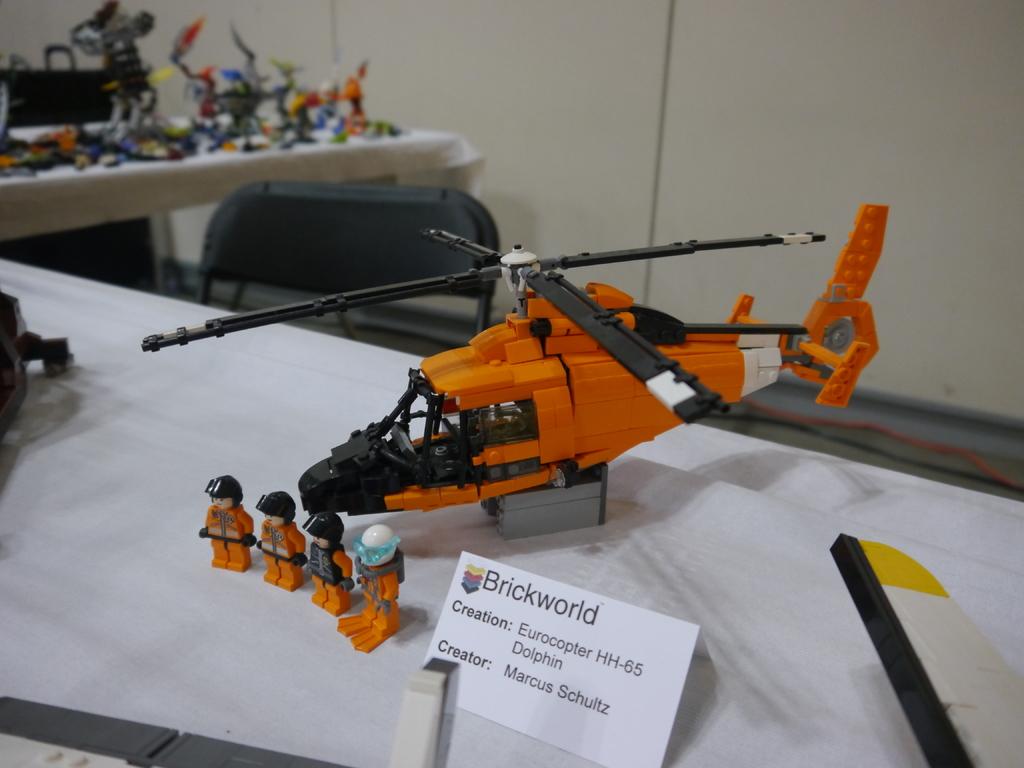Who created the lego helicopter?
Your answer should be very brief. Marcus schultz. What world is mentioned on the card in front of the lego helicopter?
Keep it short and to the point. Brickworld. 